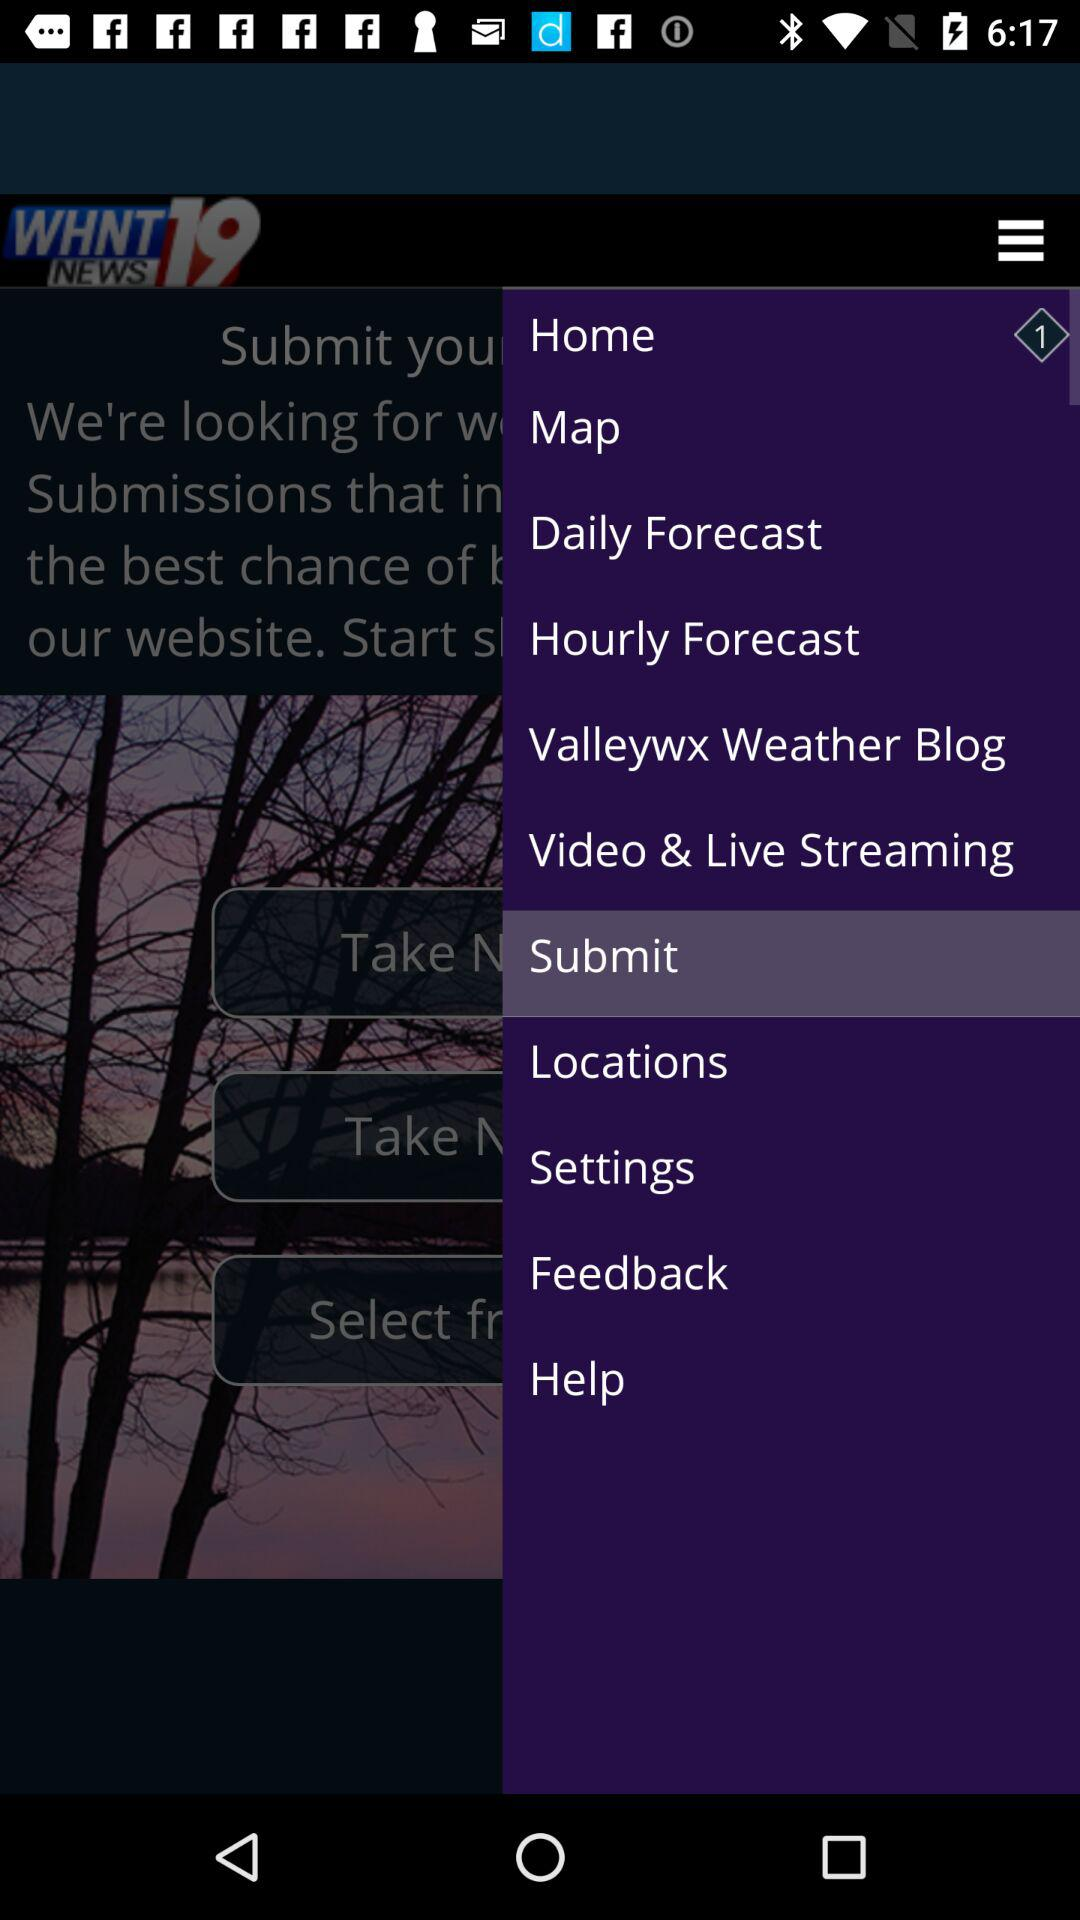Which item is selected? The selected item is "Submit". 